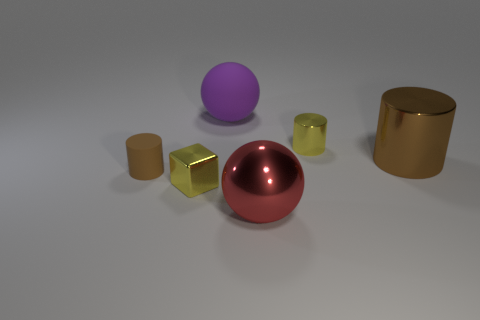There is a small cylinder that is to the right of the large ball that is left of the big ball that is in front of the small matte cylinder; what is its color?
Your answer should be compact. Yellow. Are there any other things that are the same size as the purple thing?
Ensure brevity in your answer.  Yes. There is a shiny cube; is its color the same as the big shiny thing in front of the tiny block?
Give a very brief answer. No. The large cylinder is what color?
Offer a very short reply. Brown. There is a tiny metallic thing in front of the big metallic thing behind the big sphere in front of the large purple sphere; what shape is it?
Ensure brevity in your answer.  Cube. What number of other things are there of the same color as the small cube?
Keep it short and to the point. 1. Are there more big purple rubber things in front of the big purple object than tiny brown matte objects that are to the right of the tiny yellow block?
Give a very brief answer. No. Are there any large cylinders to the left of the big metallic cylinder?
Ensure brevity in your answer.  No. There is a big thing that is to the left of the tiny yellow cylinder and in front of the big purple ball; what material is it?
Your answer should be compact. Metal. What color is the large shiny thing that is the same shape as the small matte thing?
Keep it short and to the point. Brown. 